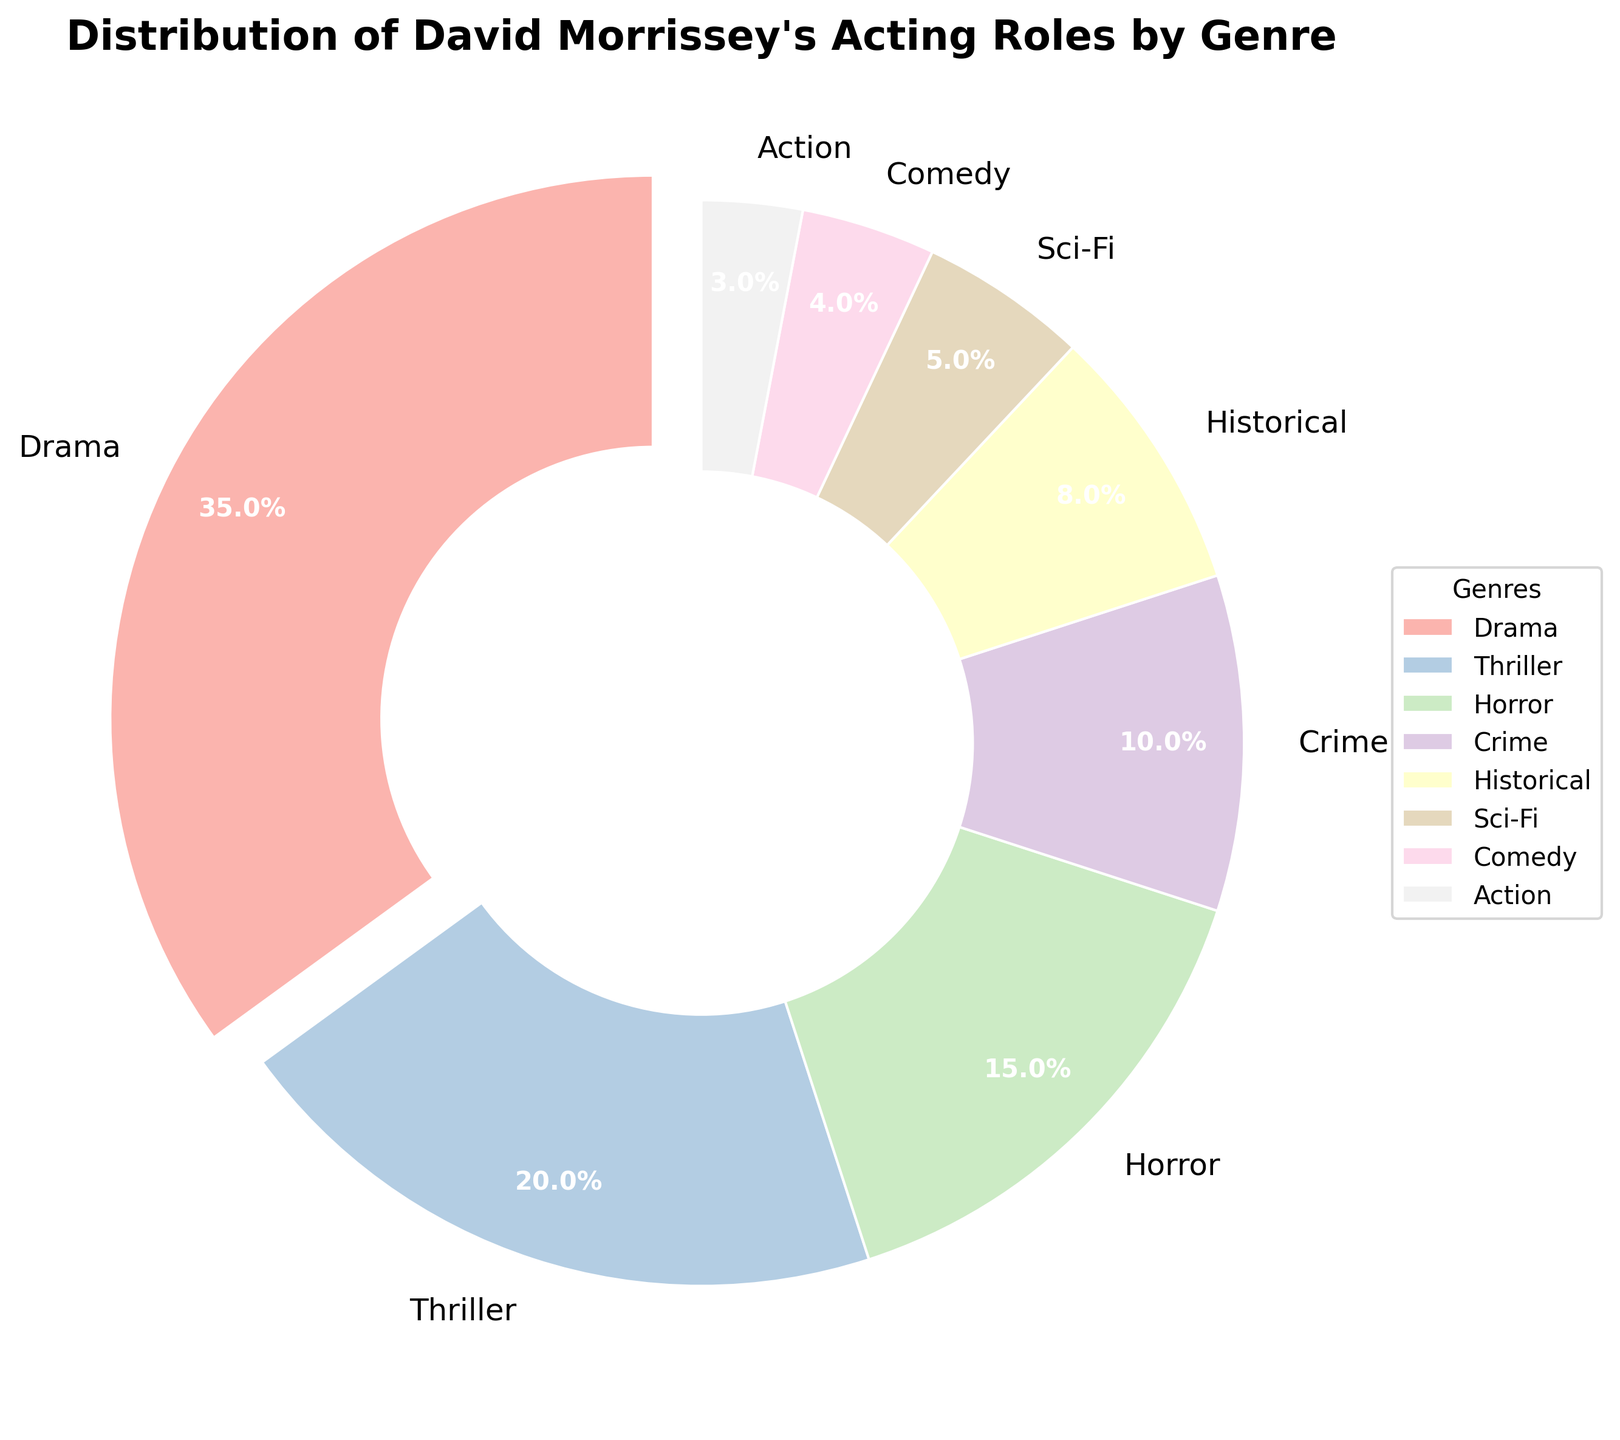What genre has the highest percentage of David Morrissey's acting roles? Look at the pie chart and find the genre with the largest segment. The biggest segment is "Drama," accounting for 35% of the roles.
Answer: Drama Which two genres together account for the majority (over 50%) of David Morrissey's acting roles? Add up the percentages for the genres with the largest segments until the sum exceeds 50%. "Drama" is 35% and "Thriller" is 20%, which together make 55%, more than half.
Answer: Drama and Thriller What is the total percentage of roles in Historical, Sci-Fi, Comedy, and Action combined? Add the given percentages: Historical (8%) + Sci-Fi (5%) + Comedy (4%) + Action (3%) = 20%.
Answer: 20% Which genre occupies the smallest segment in the pie chart? Identify the smallest segment by visual inspection. "Action" occupies the smallest segment with 3%
Answer: Action How much more percentage does Drama comprise compared to Horror? Subtract the percentage of Horror from the percentage of Drama: Drama (35%) - Horror (15%) = 20%.
Answer: 20% Are the combined roles in Sci-Fi and Comedy more than or less than those in Crime? Add the percentages of Sci-Fi and Comedy then compare with Crime: Sci-Fi (5%) + Comedy (4%) = 9%, which is less than Crime (10%).
Answer: Less than How does the percentage of Thriller roles compare to the combined percentages of Historical and Action roles? Sum the percentages of Historical and Action and compare to Thriller: Historical (8%) + Action (3%) = 11%, which is less than Thriller (20%).
Answer: Greater than Which genre's segment is colored differently in the pie chart due to its highest percentage? The segment with the highest percentage is "Drama" and is visually differentiated.
Answer: Drama What percentage of David Morrissey's roles can be found in either Crime or Historical genres? Add the percentages for Crime and Historical: Crime (10%) + Historical (8%) = 18%.
Answer: 18% Is Thriller closer in percentage to Drama or Horror? Calculate the absolute difference between Thriller and both Drama and Horror: Thriller (20%) vs Drama (35%) is 15%, and Thriller (20%) vs Horror (15%) is 5%. Thriller is closer to Horror.
Answer: Horror 